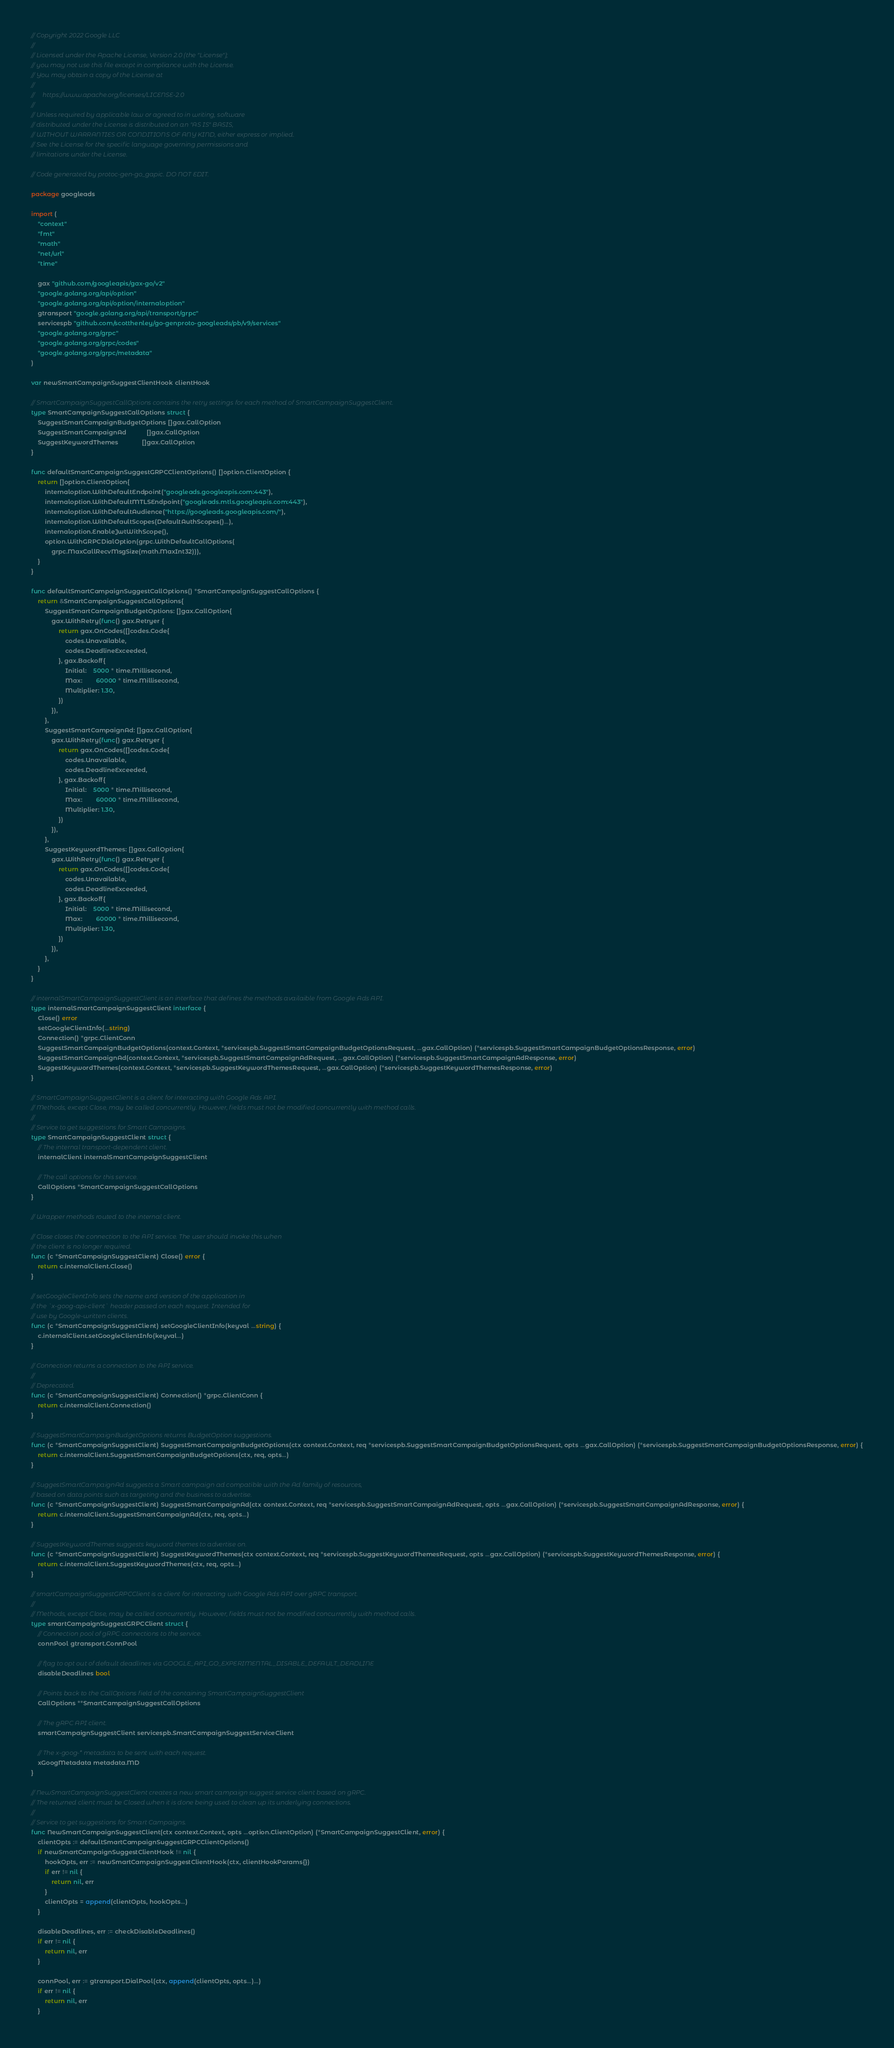<code> <loc_0><loc_0><loc_500><loc_500><_Go_>// Copyright 2022 Google LLC
//
// Licensed under the Apache License, Version 2.0 (the "License");
// you may not use this file except in compliance with the License.
// You may obtain a copy of the License at
//
//     https://www.apache.org/licenses/LICENSE-2.0
//
// Unless required by applicable law or agreed to in writing, software
// distributed under the License is distributed on an "AS IS" BASIS,
// WITHOUT WARRANTIES OR CONDITIONS OF ANY KIND, either express or implied.
// See the License for the specific language governing permissions and
// limitations under the License.

// Code generated by protoc-gen-go_gapic. DO NOT EDIT.

package googleads

import (
	"context"
	"fmt"
	"math"
	"net/url"
	"time"

	gax "github.com/googleapis/gax-go/v2"
	"google.golang.org/api/option"
	"google.golang.org/api/option/internaloption"
	gtransport "google.golang.org/api/transport/grpc"
	servicespb "github.com/scotthenley/go-genproto-googleads/pb/v9/services"
	"google.golang.org/grpc"
	"google.golang.org/grpc/codes"
	"google.golang.org/grpc/metadata"
)

var newSmartCampaignSuggestClientHook clientHook

// SmartCampaignSuggestCallOptions contains the retry settings for each method of SmartCampaignSuggestClient.
type SmartCampaignSuggestCallOptions struct {
	SuggestSmartCampaignBudgetOptions []gax.CallOption
	SuggestSmartCampaignAd            []gax.CallOption
	SuggestKeywordThemes              []gax.CallOption
}

func defaultSmartCampaignSuggestGRPCClientOptions() []option.ClientOption {
	return []option.ClientOption{
		internaloption.WithDefaultEndpoint("googleads.googleapis.com:443"),
		internaloption.WithDefaultMTLSEndpoint("googleads.mtls.googleapis.com:443"),
		internaloption.WithDefaultAudience("https://googleads.googleapis.com/"),
		internaloption.WithDefaultScopes(DefaultAuthScopes()...),
		internaloption.EnableJwtWithScope(),
		option.WithGRPCDialOption(grpc.WithDefaultCallOptions(
			grpc.MaxCallRecvMsgSize(math.MaxInt32))),
	}
}

func defaultSmartCampaignSuggestCallOptions() *SmartCampaignSuggestCallOptions {
	return &SmartCampaignSuggestCallOptions{
		SuggestSmartCampaignBudgetOptions: []gax.CallOption{
			gax.WithRetry(func() gax.Retryer {
				return gax.OnCodes([]codes.Code{
					codes.Unavailable,
					codes.DeadlineExceeded,
				}, gax.Backoff{
					Initial:    5000 * time.Millisecond,
					Max:        60000 * time.Millisecond,
					Multiplier: 1.30,
				})
			}),
		},
		SuggestSmartCampaignAd: []gax.CallOption{
			gax.WithRetry(func() gax.Retryer {
				return gax.OnCodes([]codes.Code{
					codes.Unavailable,
					codes.DeadlineExceeded,
				}, gax.Backoff{
					Initial:    5000 * time.Millisecond,
					Max:        60000 * time.Millisecond,
					Multiplier: 1.30,
				})
			}),
		},
		SuggestKeywordThemes: []gax.CallOption{
			gax.WithRetry(func() gax.Retryer {
				return gax.OnCodes([]codes.Code{
					codes.Unavailable,
					codes.DeadlineExceeded,
				}, gax.Backoff{
					Initial:    5000 * time.Millisecond,
					Max:        60000 * time.Millisecond,
					Multiplier: 1.30,
				})
			}),
		},
	}
}

// internalSmartCampaignSuggestClient is an interface that defines the methods availaible from Google Ads API.
type internalSmartCampaignSuggestClient interface {
	Close() error
	setGoogleClientInfo(...string)
	Connection() *grpc.ClientConn
	SuggestSmartCampaignBudgetOptions(context.Context, *servicespb.SuggestSmartCampaignBudgetOptionsRequest, ...gax.CallOption) (*servicespb.SuggestSmartCampaignBudgetOptionsResponse, error)
	SuggestSmartCampaignAd(context.Context, *servicespb.SuggestSmartCampaignAdRequest, ...gax.CallOption) (*servicespb.SuggestSmartCampaignAdResponse, error)
	SuggestKeywordThemes(context.Context, *servicespb.SuggestKeywordThemesRequest, ...gax.CallOption) (*servicespb.SuggestKeywordThemesResponse, error)
}

// SmartCampaignSuggestClient is a client for interacting with Google Ads API.
// Methods, except Close, may be called concurrently. However, fields must not be modified concurrently with method calls.
//
// Service to get suggestions for Smart Campaigns.
type SmartCampaignSuggestClient struct {
	// The internal transport-dependent client.
	internalClient internalSmartCampaignSuggestClient

	// The call options for this service.
	CallOptions *SmartCampaignSuggestCallOptions
}

// Wrapper methods routed to the internal client.

// Close closes the connection to the API service. The user should invoke this when
// the client is no longer required.
func (c *SmartCampaignSuggestClient) Close() error {
	return c.internalClient.Close()
}

// setGoogleClientInfo sets the name and version of the application in
// the `x-goog-api-client` header passed on each request. Intended for
// use by Google-written clients.
func (c *SmartCampaignSuggestClient) setGoogleClientInfo(keyval ...string) {
	c.internalClient.setGoogleClientInfo(keyval...)
}

// Connection returns a connection to the API service.
//
// Deprecated.
func (c *SmartCampaignSuggestClient) Connection() *grpc.ClientConn {
	return c.internalClient.Connection()
}

// SuggestSmartCampaignBudgetOptions returns BudgetOption suggestions.
func (c *SmartCampaignSuggestClient) SuggestSmartCampaignBudgetOptions(ctx context.Context, req *servicespb.SuggestSmartCampaignBudgetOptionsRequest, opts ...gax.CallOption) (*servicespb.SuggestSmartCampaignBudgetOptionsResponse, error) {
	return c.internalClient.SuggestSmartCampaignBudgetOptions(ctx, req, opts...)
}

// SuggestSmartCampaignAd suggests a Smart campaign ad compatible with the Ad family of resources,
// based on data points such as targeting and the business to advertise.
func (c *SmartCampaignSuggestClient) SuggestSmartCampaignAd(ctx context.Context, req *servicespb.SuggestSmartCampaignAdRequest, opts ...gax.CallOption) (*servicespb.SuggestSmartCampaignAdResponse, error) {
	return c.internalClient.SuggestSmartCampaignAd(ctx, req, opts...)
}

// SuggestKeywordThemes suggests keyword themes to advertise on.
func (c *SmartCampaignSuggestClient) SuggestKeywordThemes(ctx context.Context, req *servicespb.SuggestKeywordThemesRequest, opts ...gax.CallOption) (*servicespb.SuggestKeywordThemesResponse, error) {
	return c.internalClient.SuggestKeywordThemes(ctx, req, opts...)
}

// smartCampaignSuggestGRPCClient is a client for interacting with Google Ads API over gRPC transport.
//
// Methods, except Close, may be called concurrently. However, fields must not be modified concurrently with method calls.
type smartCampaignSuggestGRPCClient struct {
	// Connection pool of gRPC connections to the service.
	connPool gtransport.ConnPool

	// flag to opt out of default deadlines via GOOGLE_API_GO_EXPERIMENTAL_DISABLE_DEFAULT_DEADLINE
	disableDeadlines bool

	// Points back to the CallOptions field of the containing SmartCampaignSuggestClient
	CallOptions **SmartCampaignSuggestCallOptions

	// The gRPC API client.
	smartCampaignSuggestClient servicespb.SmartCampaignSuggestServiceClient

	// The x-goog-* metadata to be sent with each request.
	xGoogMetadata metadata.MD
}

// NewSmartCampaignSuggestClient creates a new smart campaign suggest service client based on gRPC.
// The returned client must be Closed when it is done being used to clean up its underlying connections.
//
// Service to get suggestions for Smart Campaigns.
func NewSmartCampaignSuggestClient(ctx context.Context, opts ...option.ClientOption) (*SmartCampaignSuggestClient, error) {
	clientOpts := defaultSmartCampaignSuggestGRPCClientOptions()
	if newSmartCampaignSuggestClientHook != nil {
		hookOpts, err := newSmartCampaignSuggestClientHook(ctx, clientHookParams{})
		if err != nil {
			return nil, err
		}
		clientOpts = append(clientOpts, hookOpts...)
	}

	disableDeadlines, err := checkDisableDeadlines()
	if err != nil {
		return nil, err
	}

	connPool, err := gtransport.DialPool(ctx, append(clientOpts, opts...)...)
	if err != nil {
		return nil, err
	}</code> 